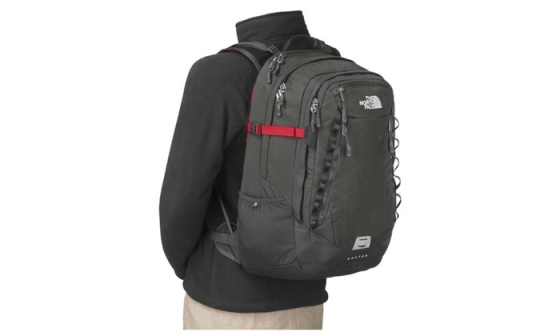Imagine you are preparing for a hiking adventure, how would this backpack serve you? As a hiking companion, the North Face backpack is an excellent choice due to its multiple features designed for functionality and comfort. The spacious compartments can store essential gear such as maps, compasses, first-aid kits, snacks, and extra clothing layers. The durable, weather-resistant material ensures that your belongings stay protected from the elements. The ergonomic design, with its padded, adjustable shoulder straps, helps to evenly distribute the weight, preventing strain during long hikes. The red chest strap adds extra stability, keeping the backpack securely in place even on rugged terrain. The side pockets are perfect for water bottles or other hydration systems, ensuring you can stay refreshed without needing to dig through the main compartments. Overall, this backpack combines practicality with comfort, making it ideal for any hiking adventure.  If this backpack were a character in a fantasy story, what would its special powers be? In a fantasy story, this North Face backpack could be endowed with magical powers fitting its robust and practical nature. Imagine it as the 'Enchanted Pack of Infinite Holding.' This extraordinary backpack would have the ability to store an infinite amount of items without ever getting heavy, thanks to its interdimensional storage pockets. The red chest strap could glow when danger is near, acting as a protective charm that also increases the wearer's strength and agility. The white North Face logo would serve as a mystical emblem, enabling the bearer to endure harsh weather conditions and providing warmth in cold climates. Each zipper could lock in place with a spell, ensuring the safety of the contents within, while the side pockets could purify any liquid placed inside them, providing endless clean water. Such a backpack would be the ultimate tool for any adventurer in a magical realm, offering both practicality and a touch of wonder. 